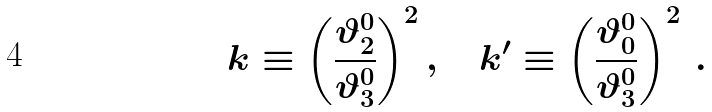Convert formula to latex. <formula><loc_0><loc_0><loc_500><loc_500>k \equiv \left ( { \frac { \vartheta _ { 2 } ^ { 0 } } { \vartheta _ { 3 } ^ { 0 } } } \right ) ^ { 2 } , \quad k ^ { \prime } \equiv \left ( { \frac { \vartheta _ { 0 } ^ { 0 } } { \vartheta _ { 3 } ^ { 0 } } } \right ) ^ { 2 } \, .</formula> 